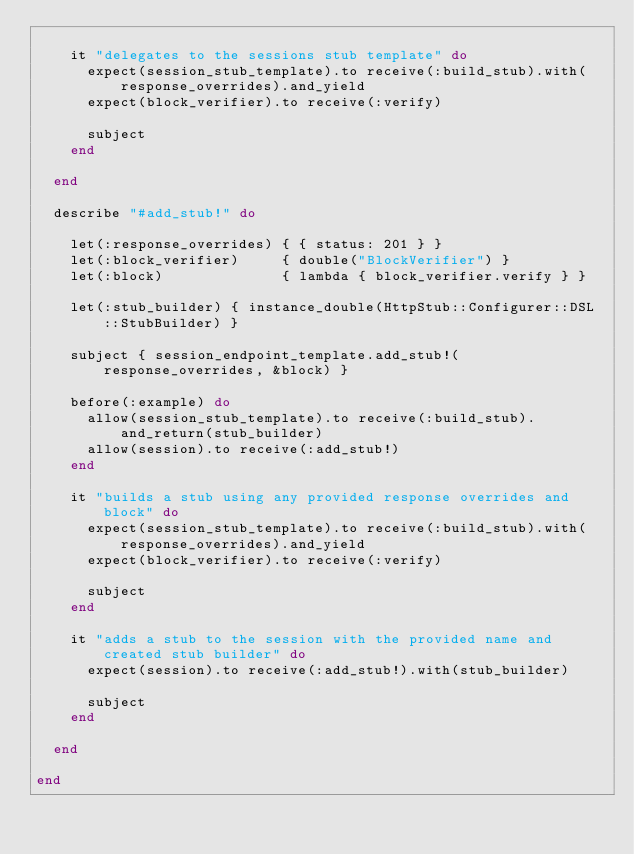<code> <loc_0><loc_0><loc_500><loc_500><_Ruby_>
    it "delegates to the sessions stub template" do
      expect(session_stub_template).to receive(:build_stub).with(response_overrides).and_yield
      expect(block_verifier).to receive(:verify)

      subject
    end

  end

  describe "#add_stub!" do

    let(:response_overrides) { { status: 201 } }
    let(:block_verifier)     { double("BlockVerifier") }
    let(:block)              { lambda { block_verifier.verify } }

    let(:stub_builder) { instance_double(HttpStub::Configurer::DSL::StubBuilder) }

    subject { session_endpoint_template.add_stub!(response_overrides, &block) }

    before(:example) do
      allow(session_stub_template).to receive(:build_stub).and_return(stub_builder)
      allow(session).to receive(:add_stub!)
    end

    it "builds a stub using any provided response overrides and block" do
      expect(session_stub_template).to receive(:build_stub).with(response_overrides).and_yield
      expect(block_verifier).to receive(:verify)

      subject
    end

    it "adds a stub to the session with the provided name and created stub builder" do
      expect(session).to receive(:add_stub!).with(stub_builder)

      subject
    end

  end

end
</code> 